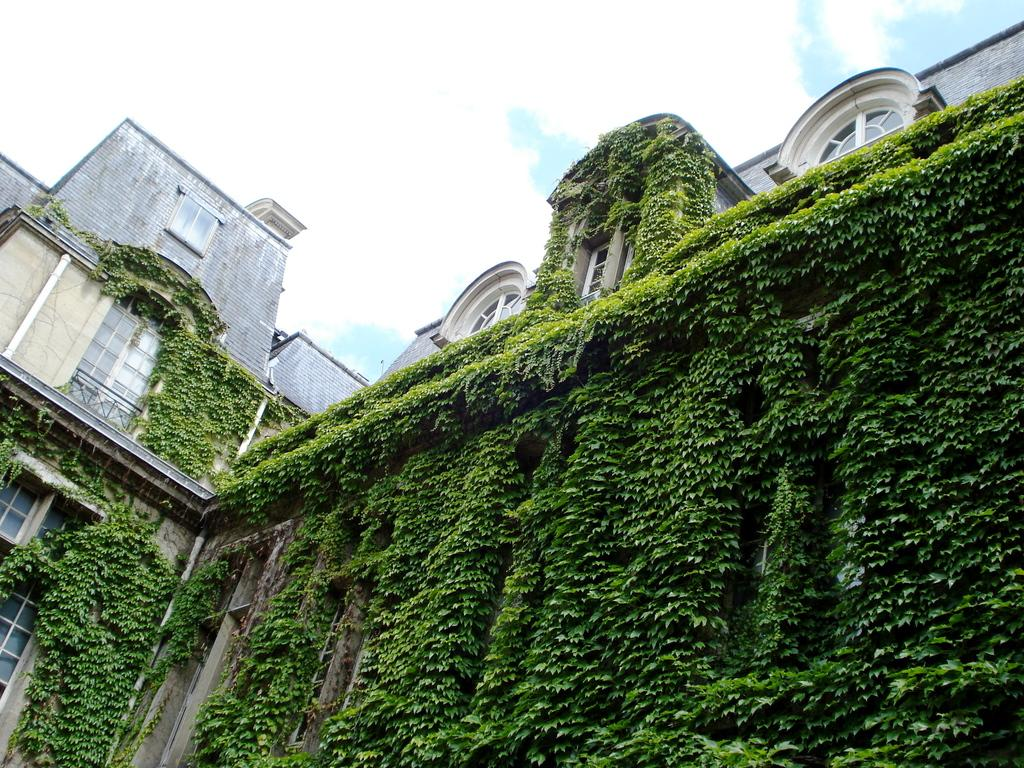What type of vegetation is growing on the building in the image? There are climbing plants on the building. What can be seen in the sky in the image? There are clouds in the sky. How many dogs can be seen playing in harmony in the image? There are no dogs present in the image, and therefore no such activity can be observed. What type of noise can be heard coming from the clouds in the image? There is no sound or noise present in the image, as it is a static visual representation. 